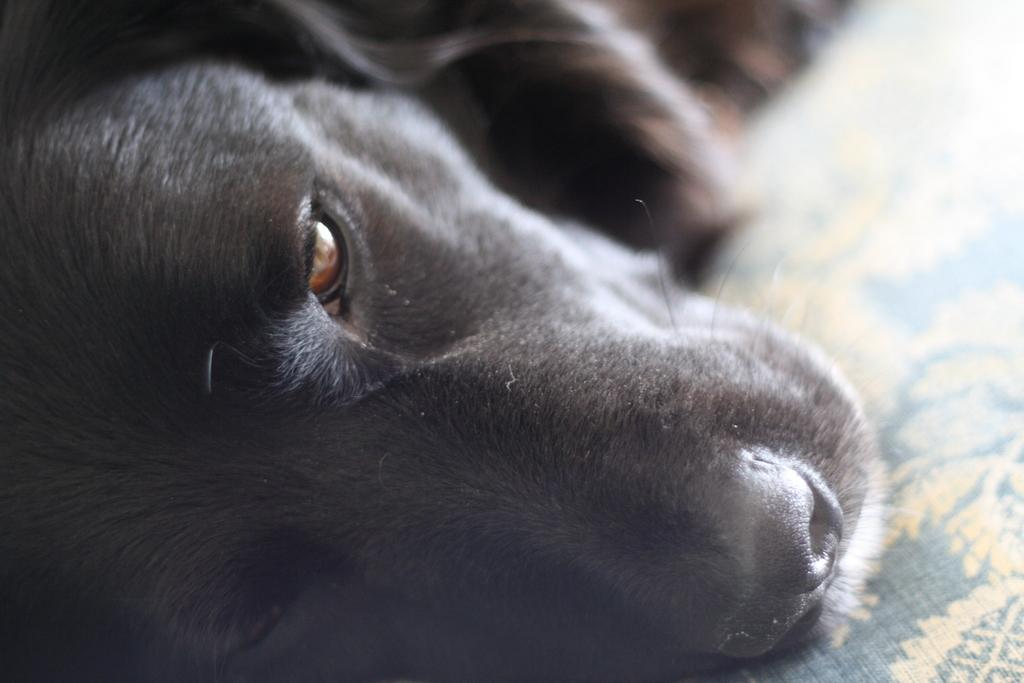What is the main subject in the foreground of the image? There is a dog in the foreground of the image. What is located at the bottom of the image? There is a mat at the bottom of the image. What type of secretary can be seen working in the background of the image? There is no secretary present in the image; it only features a dog in the foreground and a mat at the bottom. 